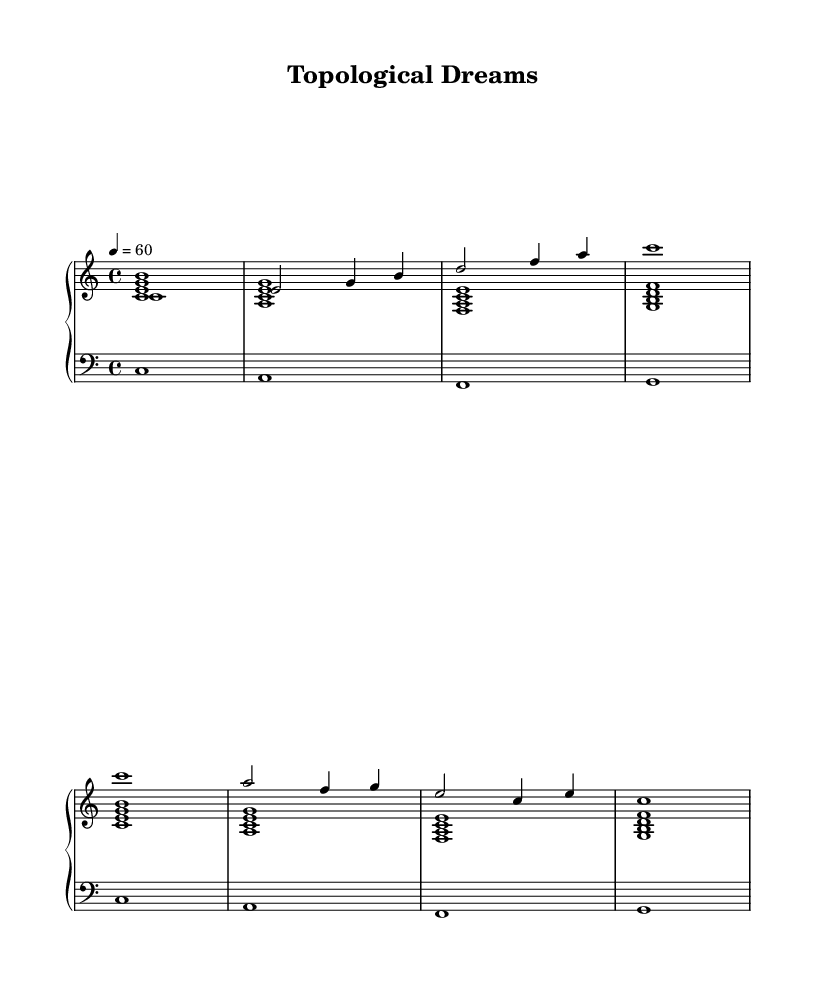What is the key signature of this music? The key signature is C major, which has no sharps or flats.
Answer: C major What is the time signature of this music? The time signature is indicated by the 4/4 symbol, which means there are four beats in each measure and the quarter note gets one beat.
Answer: 4/4 What is the tempo marking for this composition? The tempo marking is provided as "4 = 60," indicating that the quarter note has a value of sixty beats per minute.
Answer: 60 How many measures are in the melody? By counting the vertical bar lines, we see there are eight measures in the melody.
Answer: 8 What is the highest note in the melody? Looking through the notes written in the melody part, the highest note is B, which is played in the second measure.
Answer: B What type of electronic music concept is represented here? The music is inspired by mathematical concepts and geometric shapes, reflecting patterns and structures found in topology.
Answer: Topological Which notes form the harmony in the first measure? The first measure of harmony consists of the notes C, E, and G, which together form a C major chord.
Answer: C E G 